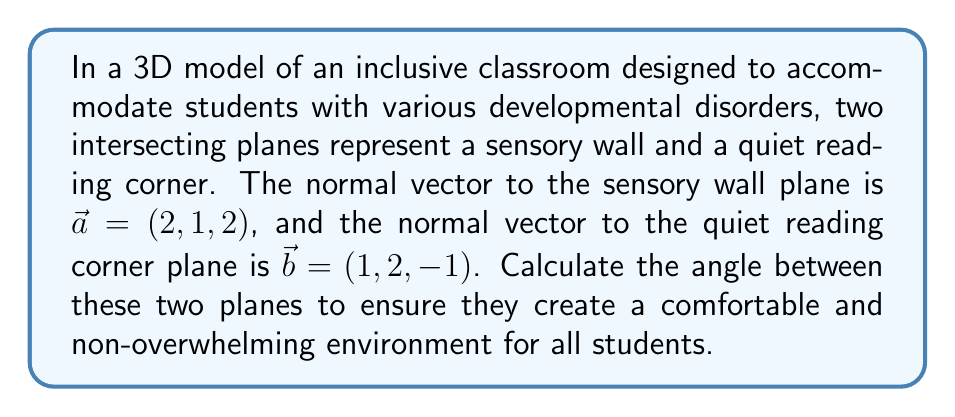Can you solve this math problem? To find the angle between two intersecting planes, we can use the dot product of their normal vectors. The formula for the angle $\theta$ between two planes with normal vectors $\vec{a}$ and $\vec{b}$ is:

$$\cos \theta = \frac{|\vec{a} \cdot \vec{b}|}{\|\vec{a}\| \|\vec{b}\|}$$

Let's solve this step by step:

1. Calculate the dot product $\vec{a} \cdot \vec{b}$:
   $$\vec{a} \cdot \vec{b} = (2)(1) + (1)(2) + (2)(-1) = 2 + 2 - 2 = 2$$

2. Calculate the magnitudes of $\vec{a}$ and $\vec{b}$:
   $$\|\vec{a}\| = \sqrt{2^2 + 1^2 + 2^2} = \sqrt{9} = 3$$
   $$\|\vec{b}\| = \sqrt{1^2 + 2^2 + (-1)^2} = \sqrt{6}$$

3. Substitute these values into the formula:
   $$\cos \theta = \frac{|2|}{3 \sqrt{6}}$$

4. Simplify:
   $$\cos \theta = \frac{2}{3\sqrt{6}} = \frac{2\sqrt{6}}{18}$$

5. To find $\theta$, take the inverse cosine (arccos) of both sides:
   $$\theta = \arccos\left(\frac{2\sqrt{6}}{18}\right)$$

6. Calculate the result (in radians):
   $$\theta \approx 1.249 \text{ radians}$$

7. Convert to degrees:
   $$\theta \approx 71.57°$$
Answer: The angle between the two planes is approximately $71.57°$ or $1.249$ radians. 